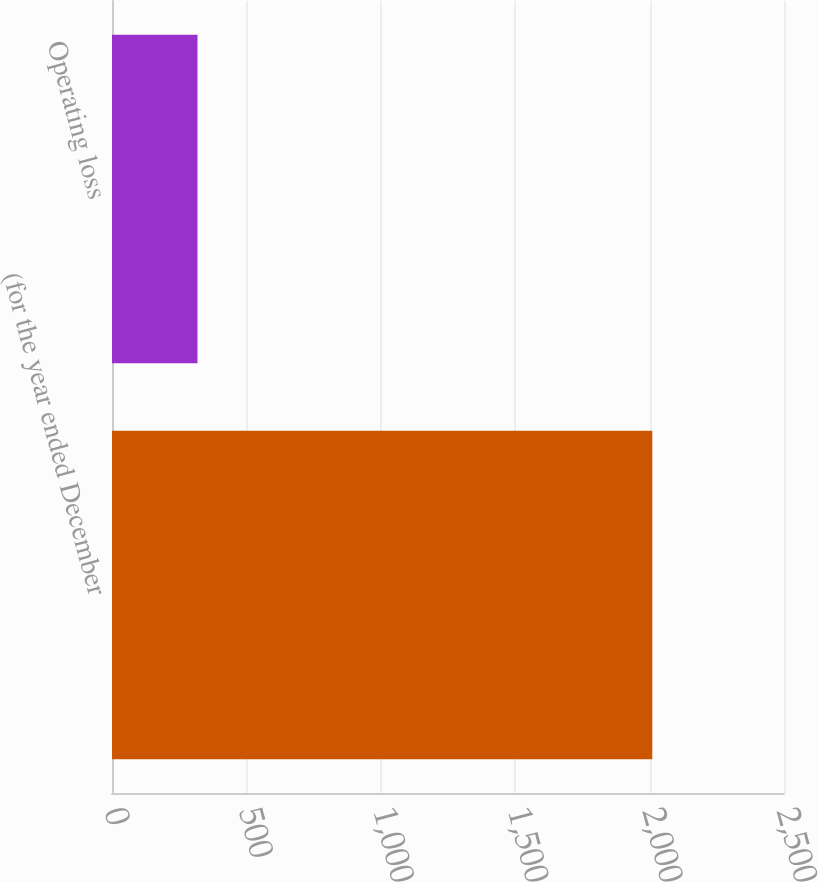Convert chart. <chart><loc_0><loc_0><loc_500><loc_500><bar_chart><fcel>(for the year ended December<fcel>Operating loss<nl><fcel>2010<fcel>318<nl></chart> 